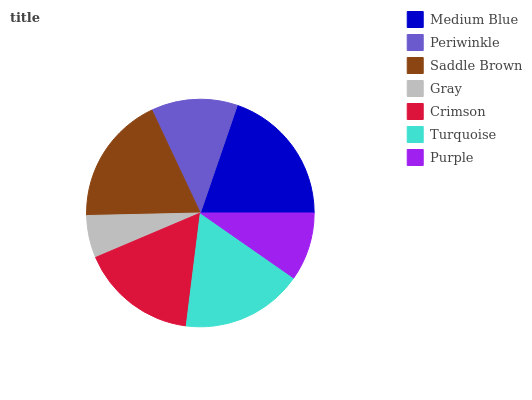Is Gray the minimum?
Answer yes or no. Yes. Is Medium Blue the maximum?
Answer yes or no. Yes. Is Periwinkle the minimum?
Answer yes or no. No. Is Periwinkle the maximum?
Answer yes or no. No. Is Medium Blue greater than Periwinkle?
Answer yes or no. Yes. Is Periwinkle less than Medium Blue?
Answer yes or no. Yes. Is Periwinkle greater than Medium Blue?
Answer yes or no. No. Is Medium Blue less than Periwinkle?
Answer yes or no. No. Is Crimson the high median?
Answer yes or no. Yes. Is Crimson the low median?
Answer yes or no. Yes. Is Saddle Brown the high median?
Answer yes or no. No. Is Purple the low median?
Answer yes or no. No. 